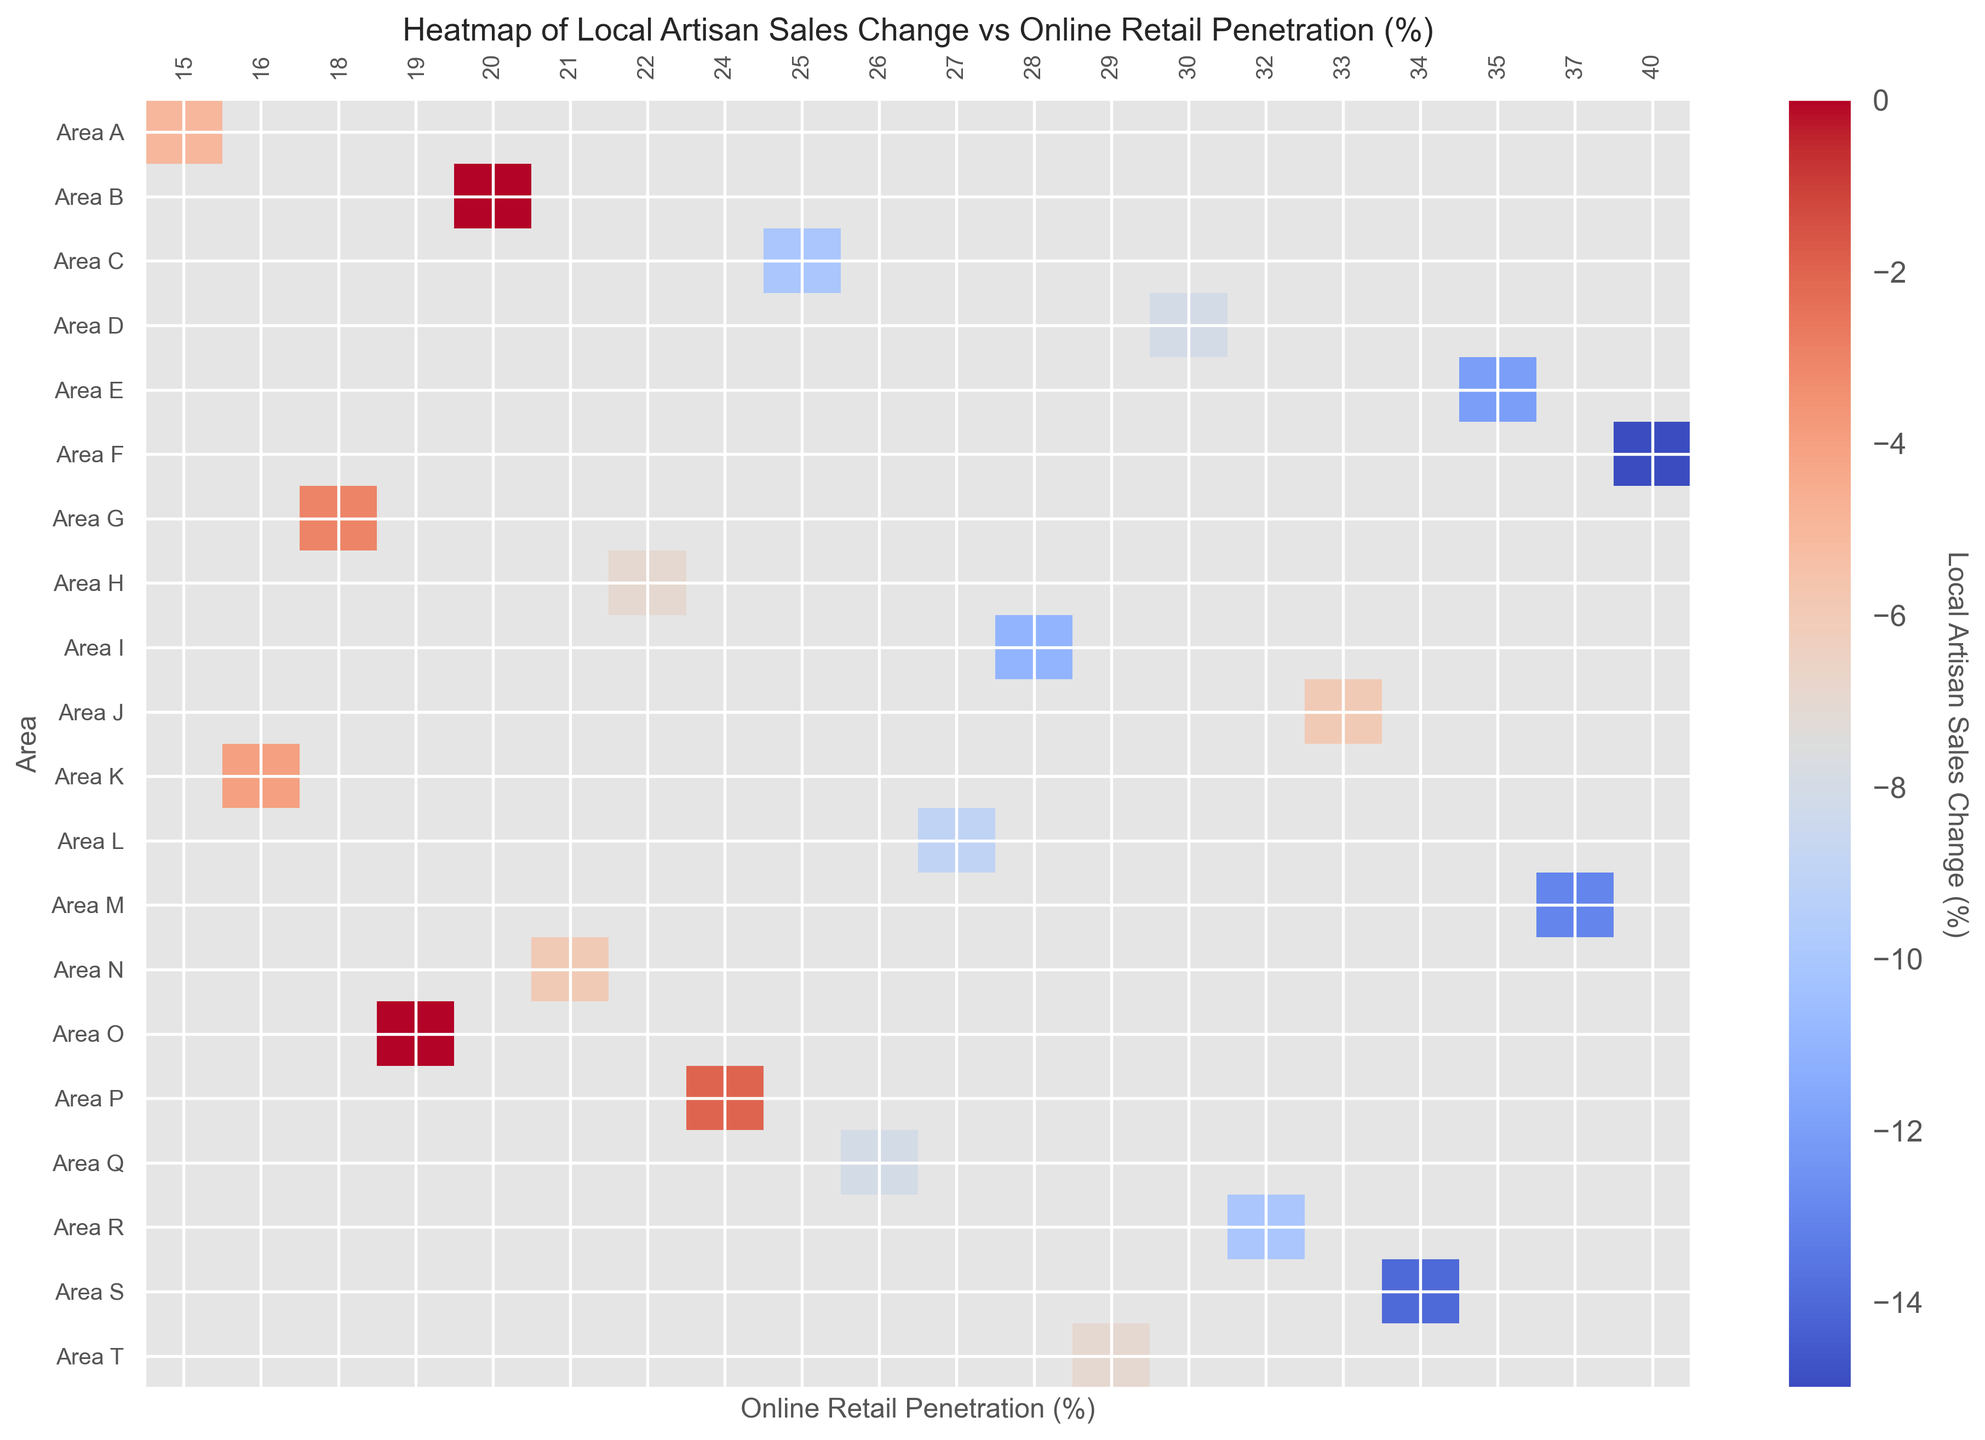What is the trend observed in local artisan sales change as online retail penetration increases? The heatmap would show that areas with higher online retail penetration generally exhibit more negative changes in local artisan sales. You would observe darker (more negative) sales change percentages where the online retail penetration is higher.
Answer: More negative sales change Which area shows the least negative change in local artisan sales, and what is its online retail penetration? By looking at the least negative color (perhaps the lightest shade) on the heatmap and checking its corresponding area, you find that Area O shows 0% sales change. The matching online retail penetration percentage would be around 19%.
Answer: Area O, 19% Which areas have shown a local artisan sales change of -10%, and what are their online retail penetration rates? By locating the color corresponding to -10% sales change on the heatmap, you can visually identify the areas and their respective columns for online retail penetration. The relevant areas are Area C, Area I, and Area R with online retail penetrations of 25%, 28%, and 32%, respectively.
Answer: Areas C, I, R; 25%, 28%, 32% Is there any area with a 20% online retail penetration showing a positive or zero change in local artisan sales? By checking the column labeled 20% online retail penetration, you need to identify if any cells are colored in shades representing positive or zero sales change. Area B shows a 0% change in local artisan sales.
Answer: Yes, Area B Which area has the highest online retail penetration, and what is its local artisan sales change? The heatmap column with the highest number for online retail penetration could be visually identified, and then cross-referenced to the corresponding area for the sales change value. For an online retail penetration of 40%, Area F shows a -15% change in local artisan sales, which is the darkest color at the highest online retail penetration percentage.
Answer: Area F, -15% How does the local artisan sales change in Area M compare to that in Area S? You would find both areas on the heatmap and compare the color shades representing their local artisan sales changes. Area M (-13%) and Area S (-14%) have similar dark shades, signifying close values in the negative change range. Additionally, Area S has a slightly darker color compared to Area M.
Answer: Area M is less negative than Area S What is the average local artisan sales change for areas with an online retail penetration between 20% and 30%? You would need to visually inspect and list down the areas with online retail penetration in the specified range (20% to 30%), then sum up their local artisan sales changes and divide by the number of these areas. Areas involved are B (0%), H (-7%), K (-4%), L (-9%), N (-6%), P (-2%), Q (-8%), and T (-7%) giving: (0 - 7 - 4 - 9 - 6 - 2 - 8 - 7)/8 = -43/8 = -5.375%
Answer: -5.375% Identify the color differences between online retail penetrations of 15% and 35%. Comparing the cells corresponding to these percentages, you can indicate their respective colors. You should expect the cell at 35% (more negative sales changes) to have a darker shade compared to the one at 15%, implying worse local artisan sales changes at higher online retail penetration rates.
Answer: 35% is darker than 15% 